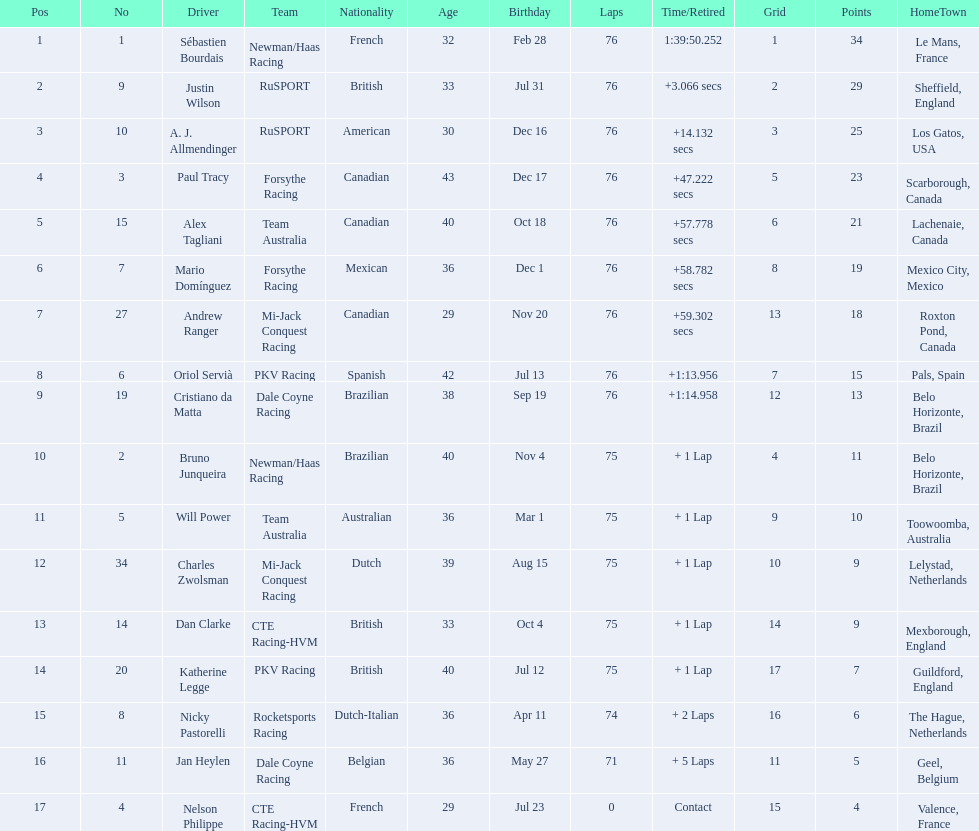Which drivers completed all 76 laps? Sébastien Bourdais, Justin Wilson, A. J. Allmendinger, Paul Tracy, Alex Tagliani, Mario Domínguez, Andrew Ranger, Oriol Servià, Cristiano da Matta. Can you parse all the data within this table? {'header': ['Pos', 'No', 'Driver', 'Team', 'Nationality', 'Age', 'Birthday', 'Laps', 'Time/Retired', 'Grid', 'Points', 'HomeTown'], 'rows': [['1', '1', 'Sébastien Bourdais', 'Newman/Haas Racing', 'French', '32', 'Feb 28', '76', '1:39:50.252', '1', '34', 'Le Mans, France'], ['2', '9', 'Justin Wilson', 'RuSPORT', 'British', '33', 'Jul 31', '76', '+3.066 secs', '2', '29', 'Sheffield, England'], ['3', '10', 'A. J. Allmendinger', 'RuSPORT', 'American', '30', 'Dec 16', '76', '+14.132 secs', '3', '25', 'Los Gatos, USA'], ['4', '3', 'Paul Tracy', 'Forsythe Racing', 'Canadian', '43', 'Dec 17', '76', '+47.222 secs', '5', '23', 'Scarborough, Canada'], ['5', '15', 'Alex Tagliani', 'Team Australia', 'Canadian', '40', 'Oct 18', '76', '+57.778 secs', '6', '21', 'Lachenaie, Canada'], ['6', '7', 'Mario Domínguez', 'Forsythe Racing', 'Mexican', '36', 'Dec 1', '76', '+58.782 secs', '8', '19', 'Mexico City, Mexico'], ['7', '27', 'Andrew Ranger', 'Mi-Jack Conquest Racing', 'Canadian', '29', 'Nov 20', '76', '+59.302 secs', '13', '18', 'Roxton Pond, Canada'], ['8', '6', 'Oriol Servià', 'PKV Racing', 'Spanish', '42', 'Jul 13', '76', '+1:13.956', '7', '15', 'Pals, Spain'], ['9', '19', 'Cristiano da Matta', 'Dale Coyne Racing', 'Brazilian', '38', 'Sep 19', '76', '+1:14.958', '12', '13', 'Belo Horizonte, Brazil'], ['10', '2', 'Bruno Junqueira', 'Newman/Haas Racing', 'Brazilian', '40', 'Nov 4', '75', '+ 1 Lap', '4', '11', 'Belo Horizonte, Brazil'], ['11', '5', 'Will Power', 'Team Australia', 'Australian', '36', 'Mar 1', '75', '+ 1 Lap', '9', '10', 'Toowoomba, Australia'], ['12', '34', 'Charles Zwolsman', 'Mi-Jack Conquest Racing', 'Dutch', '39', 'Aug 15', '75', '+ 1 Lap', '10', '9', 'Lelystad, Netherlands'], ['13', '14', 'Dan Clarke', 'CTE Racing-HVM', 'British', '33', 'Oct 4', '75', '+ 1 Lap', '14', '9', 'Mexborough, England'], ['14', '20', 'Katherine Legge', 'PKV Racing', 'British', '40', 'Jul 12', '75', '+ 1 Lap', '17', '7', 'Guildford, England'], ['15', '8', 'Nicky Pastorelli', 'Rocketsports Racing', 'Dutch-Italian', '36', 'Apr 11', '74', '+ 2 Laps', '16', '6', 'The Hague, Netherlands'], ['16', '11', 'Jan Heylen', 'Dale Coyne Racing', 'Belgian', '36', 'May 27', '71', '+ 5 Laps', '11', '5', 'Geel, Belgium'], ['17', '4', 'Nelson Philippe', 'CTE Racing-HVM', 'French', '29', 'Jul 23', '0', 'Contact', '15', '4', 'Valence, France']]} Of these drivers, which ones finished less than a minute behind first place? Paul Tracy, Alex Tagliani, Mario Domínguez, Andrew Ranger. Of these drivers, which ones finished with a time less than 50 seconds behind first place? Justin Wilson, A. J. Allmendinger, Paul Tracy. Of these three drivers, who finished last? Paul Tracy. 